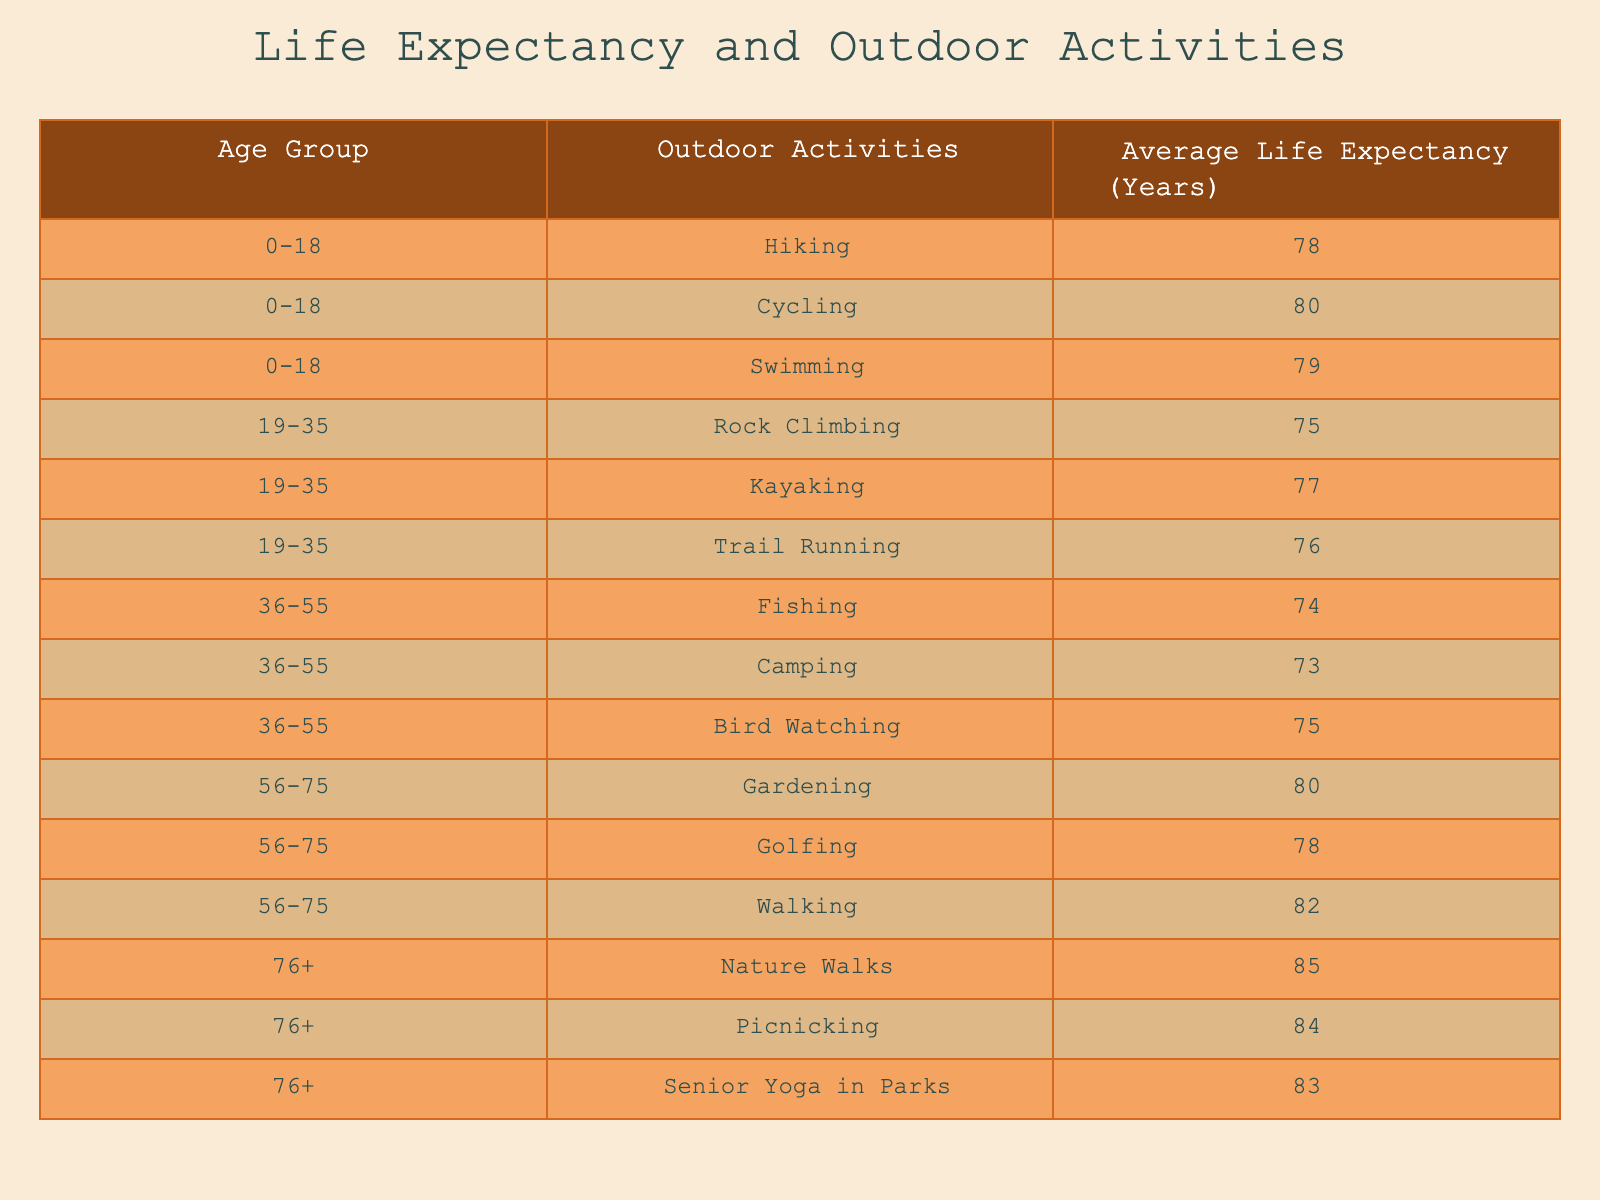What is the average life expectancy for the age group 0-18? The life expectancy values for the age group 0-18 are 78, 80, and 79. To calculate the average, sum these values: 78 + 80 + 79 = 237. Then divide by the number of activities, which is 3. So, 237 / 3 = 79.
Answer: 79 Which outdoor activity has the highest life expectancy for the age group 36-55? For the age group 36-55, the life expectancy values are 74 for Fishing, 73 for Camping, and 75 for Bird Watching. Comparing these values, the highest is 75 for Bird Watching.
Answer: Bird Watching Is the average life expectancy for outdoor activities in age group 76+ greater than that of age group 0-18? The average life expectancy for age group 76+ is calculated by summing 85, 84, and 83, which equals 252. Dividing by 3 gives an average of 84. For the age group 0-18, the average from above is 79. Since 84 is greater than 79, the statement is true.
Answer: Yes What is the difference in average life expectancy between the age groups 19-35 and 56-75? First, calculate the average life expectancy for age group 19-35: (75 + 77 + 76) / 3 = 76. For age group 56-75: (80 + 78 + 82) / 3 = 80. The difference in averages is 80 - 76 = 4.
Answer: 4 How many outdoor activities listed have a life expectancy of 80 years or more? The activities with life expectancies of 80 years or more are: Cycling (80), Gardening (80), Walking (82), Nature Walks (85), and Picnicking (84). There are a total of 5 activities that meet this criterion.
Answer: 5 What is the average life expectancy for the activities related to water-based recreation (like swimming, kayaking, and fishing)? The life expectancies related to water-based activities are: Swimming (79), Kayaking (77), and Fishing (74). To find the average, sum these values: 79 + 77 + 74 = 230. Then divide by 3, resulting in 230 / 3 = 76.67.
Answer: 76.67 